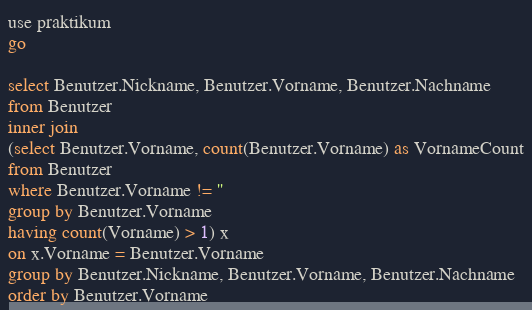Convert code to text. <code><loc_0><loc_0><loc_500><loc_500><_SQL_>use praktikum
go

select Benutzer.Nickname, Benutzer.Vorname, Benutzer.Nachname
from Benutzer
inner join
(select Benutzer.Vorname, count(Benutzer.Vorname) as VornameCount
from Benutzer
where Benutzer.Vorname != ''
group by Benutzer.Vorname
having count(Vorname) > 1) x
on x.Vorname = Benutzer.Vorname
group by Benutzer.Nickname, Benutzer.Vorname, Benutzer.Nachname
order by Benutzer.Vorname</code> 